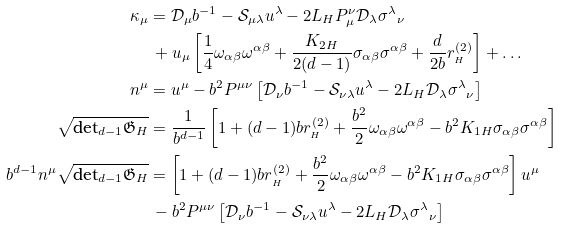Convert formula to latex. <formula><loc_0><loc_0><loc_500><loc_500>\kappa _ { \mu } & = \mathcal { D } _ { \mu } b ^ { - 1 } - \mathcal { S } _ { \mu \lambda } u ^ { \lambda } - 2 L _ { H } P _ { \mu } ^ { \nu } \mathcal { D } _ { \lambda } { \sigma ^ { \lambda } } _ { \nu } \\ & \, + u _ { \mu } \left [ \frac { 1 } { 4 } \omega _ { \alpha \beta } \omega ^ { \alpha \beta } + \frac { K _ { 2 H } } { 2 ( d - 1 ) } \sigma _ { \alpha \beta } \sigma ^ { \alpha \beta } + \frac { d } { 2 b } r _ { _ { H } } ^ { ( 2 ) } \right ] + \dots \\ n ^ { \mu } & = u ^ { \mu } - b ^ { 2 } P ^ { \mu \nu } \left [ \mathcal { D } _ { \nu } b ^ { - 1 } - \mathcal { S } _ { \nu \lambda } u ^ { \lambda } - 2 L _ { H } \mathcal { D } _ { \lambda } { \sigma ^ { \lambda } } _ { \nu } \right ] \\ \sqrt { \text {det} _ { d - 1 } \mathfrak { G } _ { H } } & = \frac { 1 } { b ^ { d - 1 } } \left [ 1 + ( d - 1 ) b r _ { _ { H } } ^ { ( 2 ) } + \frac { b ^ { 2 } } { 2 } \omega _ { \alpha \beta } \omega ^ { \alpha \beta } - b ^ { 2 } K _ { 1 H } \sigma _ { \alpha \beta } \sigma ^ { \alpha \beta } \right ] \\ b ^ { d - 1 } n ^ { \mu } \sqrt { \text {det} _ { d - 1 } \mathfrak { G } _ { H } } & = \left [ 1 + ( d - 1 ) b r _ { _ { H } } ^ { ( 2 ) } + \frac { b ^ { 2 } } { 2 } \omega _ { \alpha \beta } \omega ^ { \alpha \beta } - b ^ { 2 } K _ { 1 H } \sigma _ { \alpha \beta } \sigma ^ { \alpha \beta } \right ] u ^ { \mu } \\ & \, - b ^ { 2 } P ^ { \mu \nu } \left [ \mathcal { D } _ { \nu } b ^ { - 1 } - \mathcal { S } _ { \nu \lambda } u ^ { \lambda } - 2 L _ { H } \mathcal { D } _ { \lambda } { \sigma ^ { \lambda } } _ { \nu } \right ]</formula> 